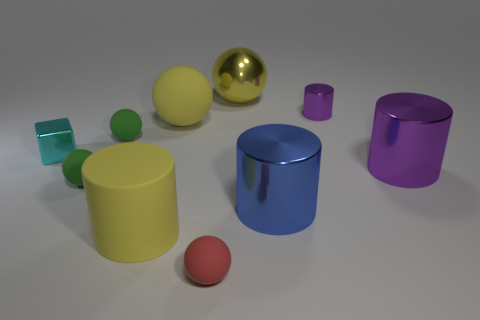Are there any reflective surfaces visible in the image? Yes, the image shows several objects with reflective surfaces. For instance, the gold sphere has a high gloss finish that reflects its surroundings, and the teal and the dark blue cylinders also have surfaces that provide a clear reflection. 